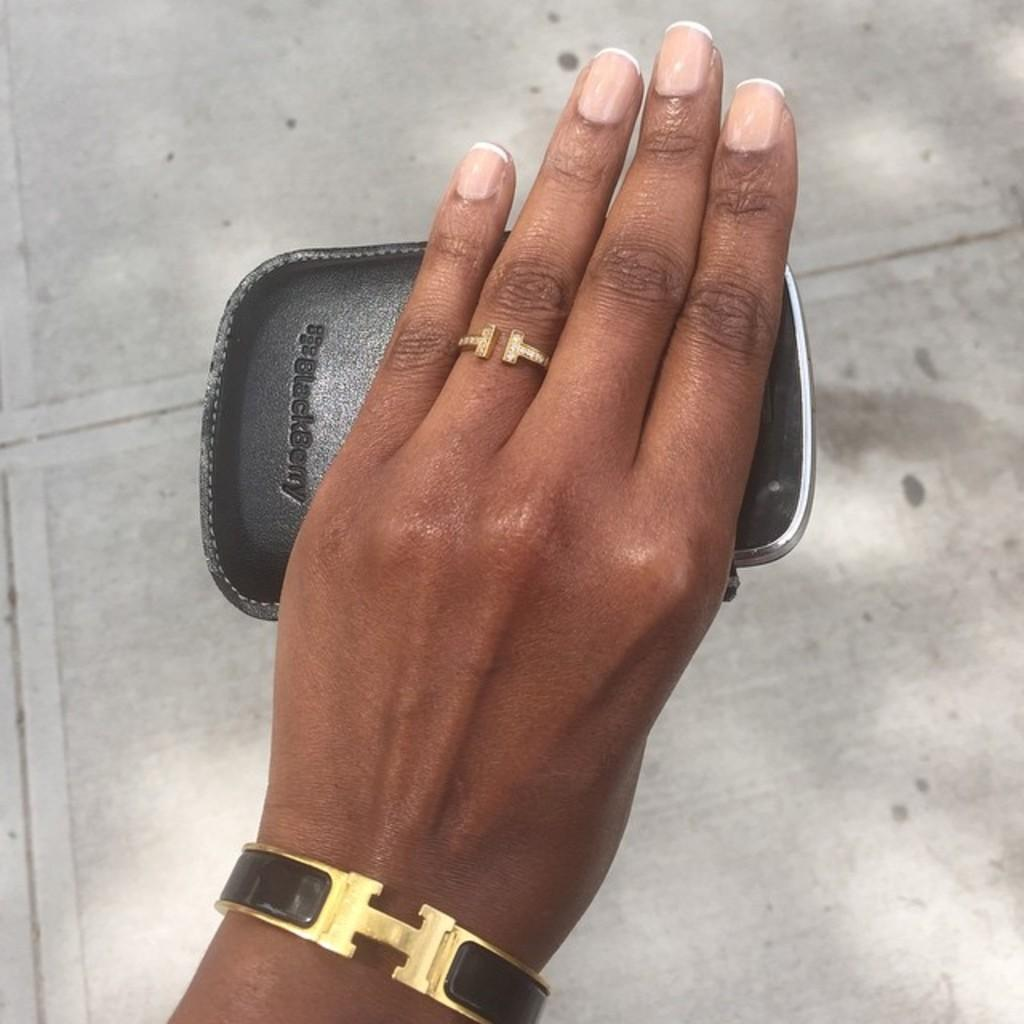<image>
Create a compact narrative representing the image presented. A hand wearing a bracelet and a ring holds a BlackBerry phone. 